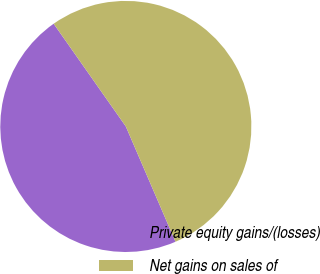<chart> <loc_0><loc_0><loc_500><loc_500><pie_chart><fcel>Private equity gains/(losses)<fcel>Net gains on sales of<nl><fcel>46.73%<fcel>53.27%<nl></chart> 